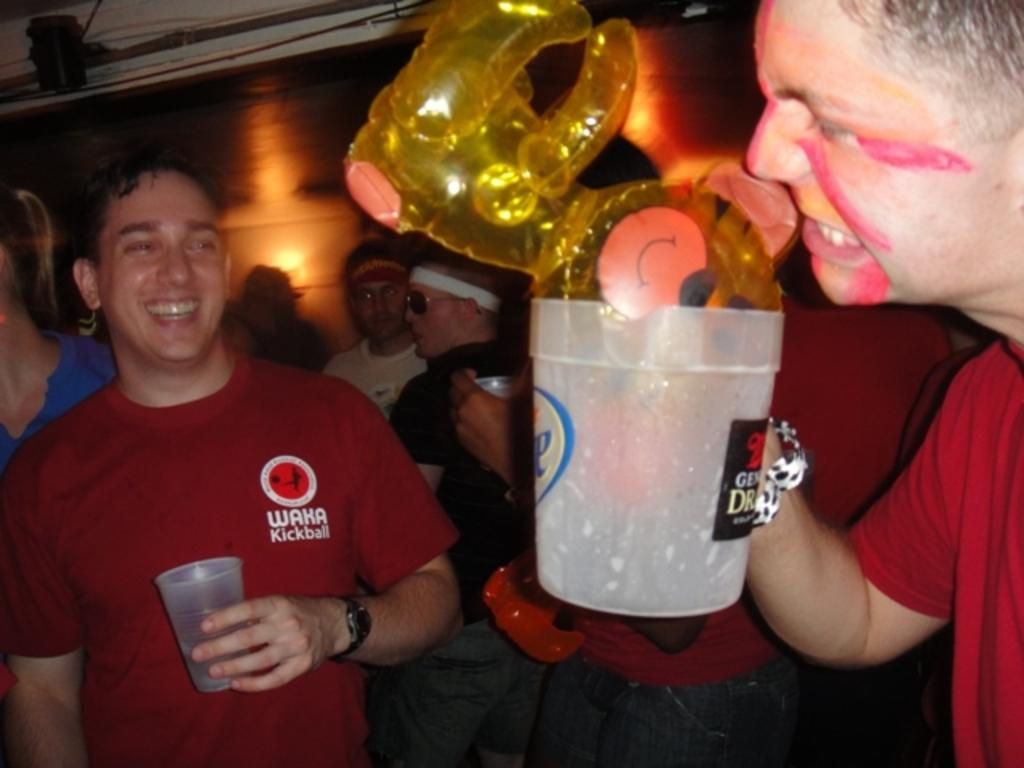What is happening in the image? There are people standing in the image. Where are the people standing? The people are standing on the floor. What are some of the people holding in the image? There are beverage tumblers in the hands of some people. How many kittens are running around the people in the image? There are no kittens present in the image, and therefore no such activity can be observed. 